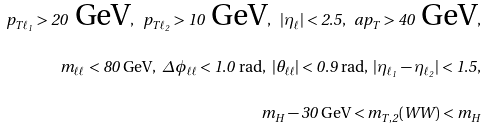Convert formula to latex. <formula><loc_0><loc_0><loc_500><loc_500>p _ { T \ell _ { 1 } } > 2 0 \text { GeV} , \ p _ { T \ell _ { 2 } } > 1 0 \text { GeV} , \ | \eta _ { \ell } | < 2 . 5 , \ \sl a { p } _ { T } > 4 0 \text { GeV} , \\ m _ { \ell \ell } < 8 0 \text { GeV} , \ \Delta \phi _ { \ell \ell } < 1 . 0 \ \text {rad} , \ | \theta _ { \ell \ell } | < 0 . 9 \ \text {rad} , \ | \eta _ { \ell _ { 1 } } - \eta _ { \ell _ { 2 } } | < 1 . 5 , \\ m _ { H } - 3 0 \text { GeV} < m _ { T , 2 } ( W W ) < m _ { H }</formula> 